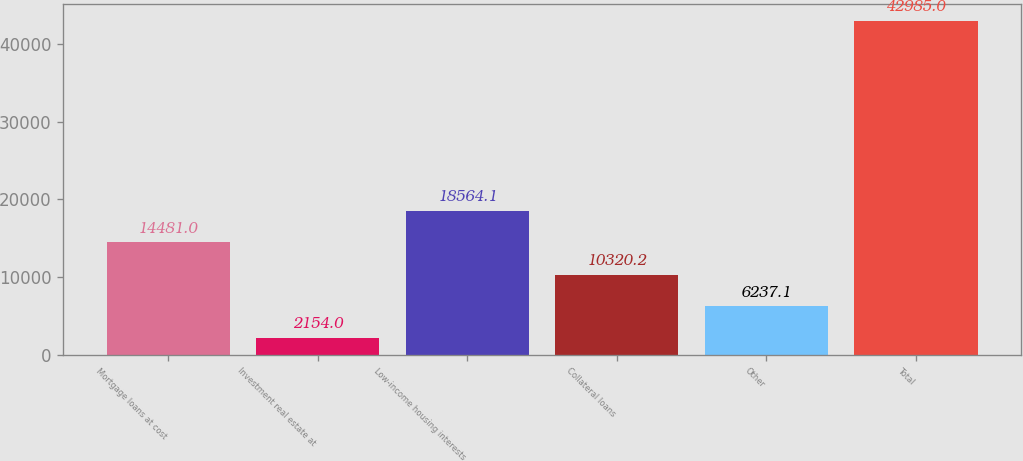Convert chart to OTSL. <chart><loc_0><loc_0><loc_500><loc_500><bar_chart><fcel>Mortgage loans at cost<fcel>Investment real estate at<fcel>Low-income housing interests<fcel>Collateral loans<fcel>Other<fcel>Total<nl><fcel>14481<fcel>2154<fcel>18564.1<fcel>10320.2<fcel>6237.1<fcel>42985<nl></chart> 